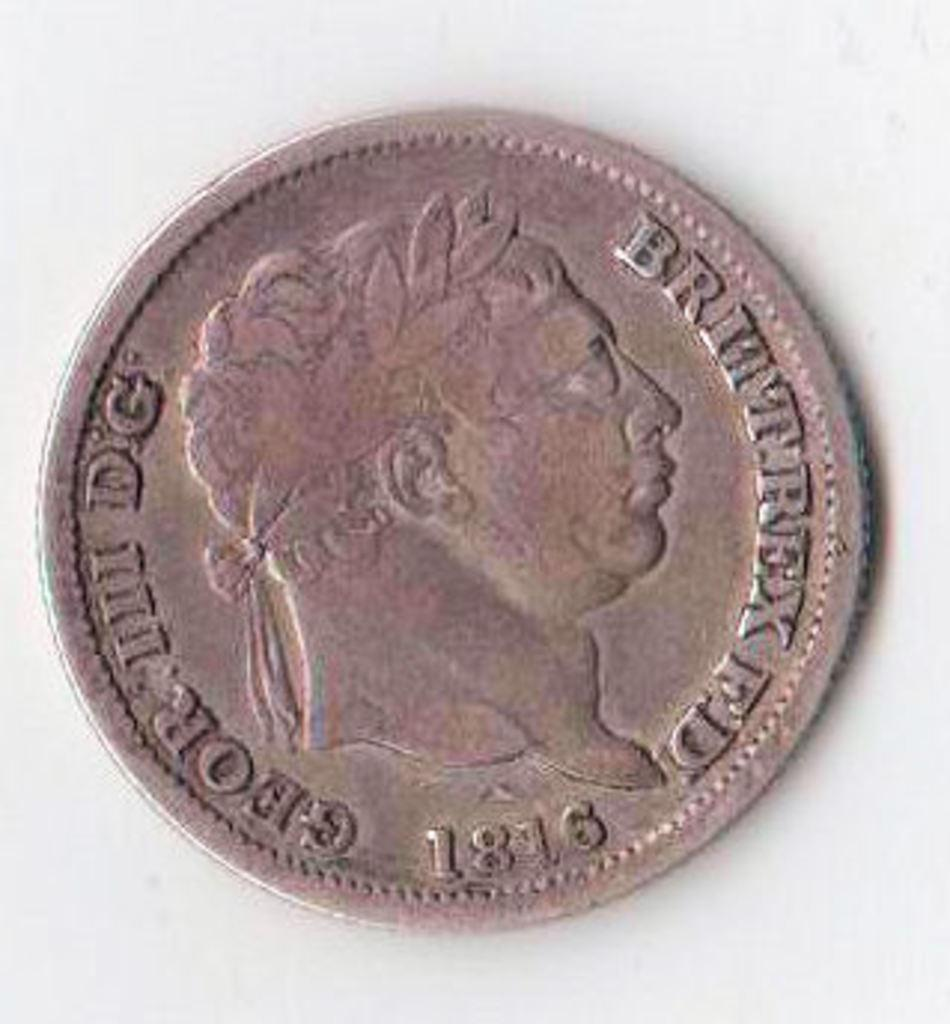What is the main subject of the image? The main subject of the image is a coin. What can be seen on the surface of the coin? There is an image of a man on the coin. Are there any words or letters on the coin? Yes, there are letters on the coin. What is the color of the background in the image? The background of the image is white in color. Can you tell me how many years are depicted on the coin? There are no years depicted on the coin; it only features an image of a man and some letters. Is there a pet visible in the image? There is no pet present in the image; it only features a coin. 